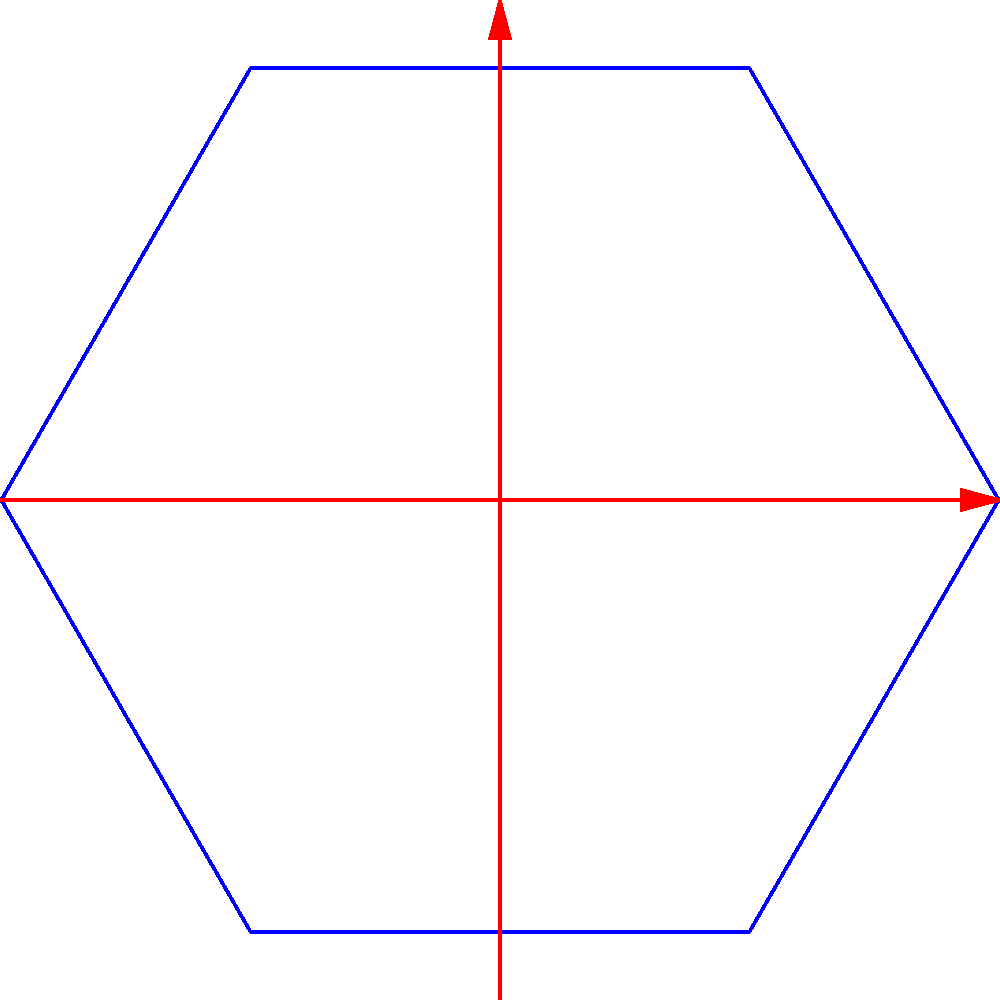In the context of contemporary Indian sustainable architecture, consider a hexagonal floor plan for a eco-friendly community center. The diagram above represents its point group symmetry. Identify the point group and explain how this symmetry contributes to the building's sustainability features. To answer this question, let's analyze the symmetry elements step-by-step:

1. Rotational symmetry:
   - The diagram shows a 6-fold rotational axis ($C_6$) perpendicular to the plane.
   - This implies rotations of 60°, 120°, 180°, 240°, 300°, and 360°.

2. Mirror planes:
   - There are two types of mirror planes visible:
     a) $\sigma_v$: Vertical mirror planes passing through the rotation axis and vertices.
     b) $\sigma_d$: Diagonal mirror planes passing through the rotation axis and edges.

3. Horizontal mirror plane:
   - Although not explicitly shown, the presence of both $\sigma_v$ and $\sigma_d$ implies a horizontal mirror plane ($\sigma_h$).

4. Inversion center:
   - The combination of $C_6$ and $\sigma_h$ produces an inversion center.

5. Point group identification:
   - The presence of $C_6$, $\sigma_v$, $\sigma_d$, $\sigma_h$, and inversion center identifies this as the $D_{6h}$ point group.

Contribution to sustainability:

1. Energy efficiency:
   - The hexagonal shape minimizes external surface area, reducing heat gain/loss.
   - Rotational symmetry allows for even distribution of sunlight throughout the day.

2. Natural ventilation:
   - Mirror planes can be utilized for creating symmetrical openings, promoting cross-ventilation.

3. Material optimization:
   - High symmetry allows for modular construction, reducing material waste.

4. Adaptability:
   - The versatile shape can be easily expanded or modified while maintaining symmetry.

5. Biophilic design:
   - Hexagonal symmetry mimics natural forms, enhancing connection with nature.

6. Water management:
   - Symmetrical roof design can facilitate efficient rainwater collection and distribution.

By incorporating these symmetry-based features, the community center can achieve improved sustainability performance while maintaining a harmonious and aesthetically pleasing design that resonates with contemporary Indian architecture.
Answer: $D_{6h}$ point group; enhances energy efficiency, natural ventilation, material optimization, adaptability, biophilic design, and water management. 